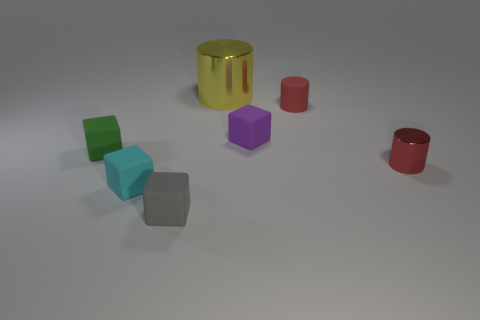Add 2 tiny cubes. How many objects exist? 9 Subtract all cylinders. How many objects are left? 4 Subtract 0 green cylinders. How many objects are left? 7 Subtract all small metallic cylinders. Subtract all spheres. How many objects are left? 6 Add 7 large yellow cylinders. How many large yellow cylinders are left? 8 Add 5 large gray metal spheres. How many large gray metal spheres exist? 5 